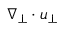<formula> <loc_0><loc_0><loc_500><loc_500>\nabla _ { \perp } \cdot u _ { \perp }</formula> 